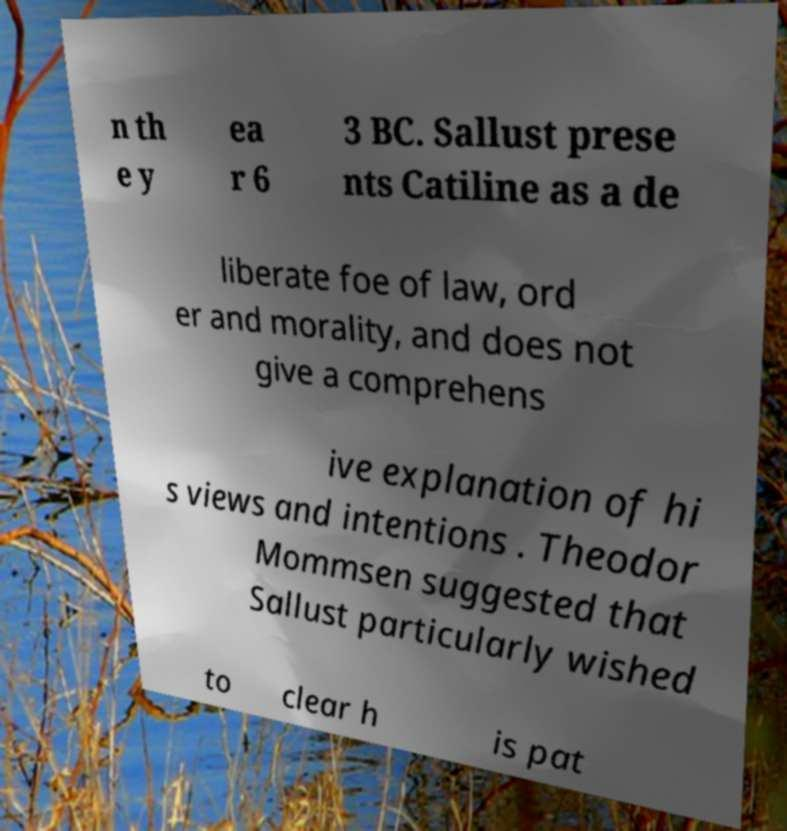There's text embedded in this image that I need extracted. Can you transcribe it verbatim? n th e y ea r 6 3 BC. Sallust prese nts Catiline as a de liberate foe of law, ord er and morality, and does not give a comprehens ive explanation of hi s views and intentions . Theodor Mommsen suggested that Sallust particularly wished to clear h is pat 